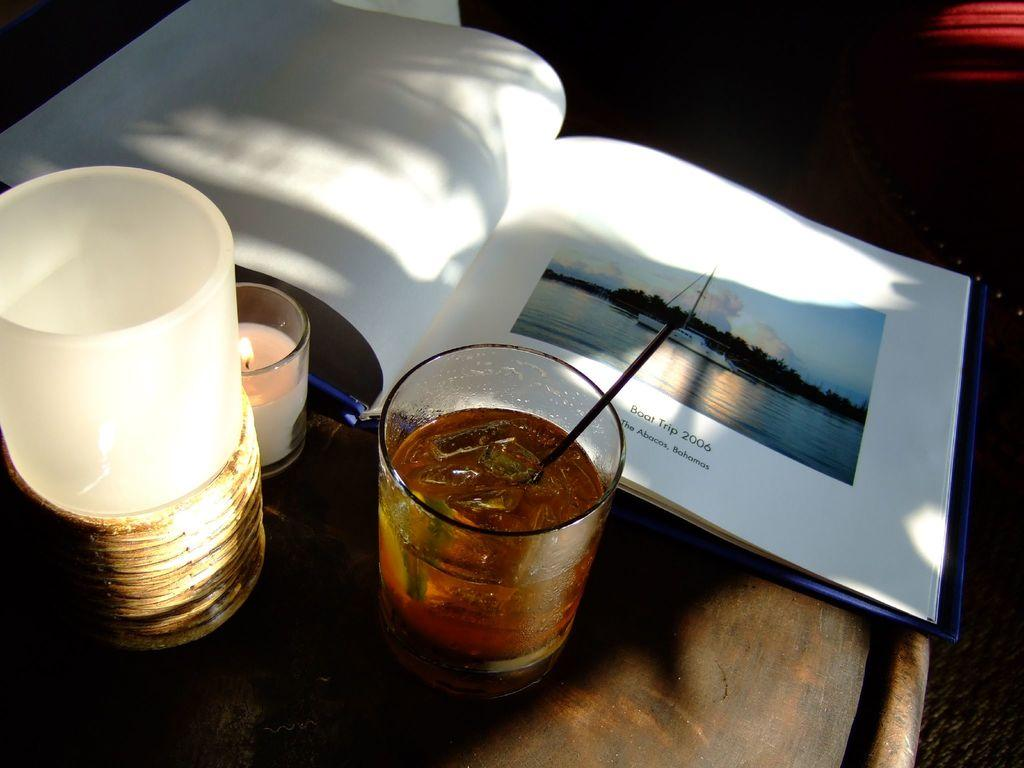<image>
Summarize the visual content of the image. A book lays open to a picture of Boat Trip 2006, The Abacos, Bahamas. 